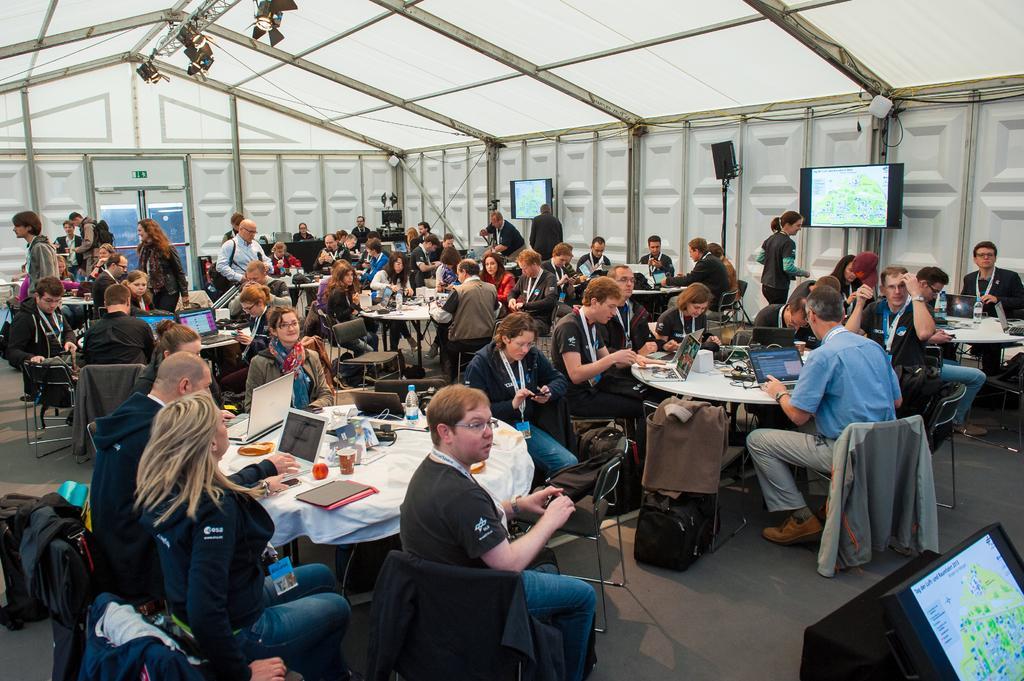Describe this image in one or two sentences. In this image, we can see people sitting on chairs in front of tables. There are some tables contains laptops. There are screens on the wall. There is an another screen in the bottom right of the image. There are lights hanging from the roof. 